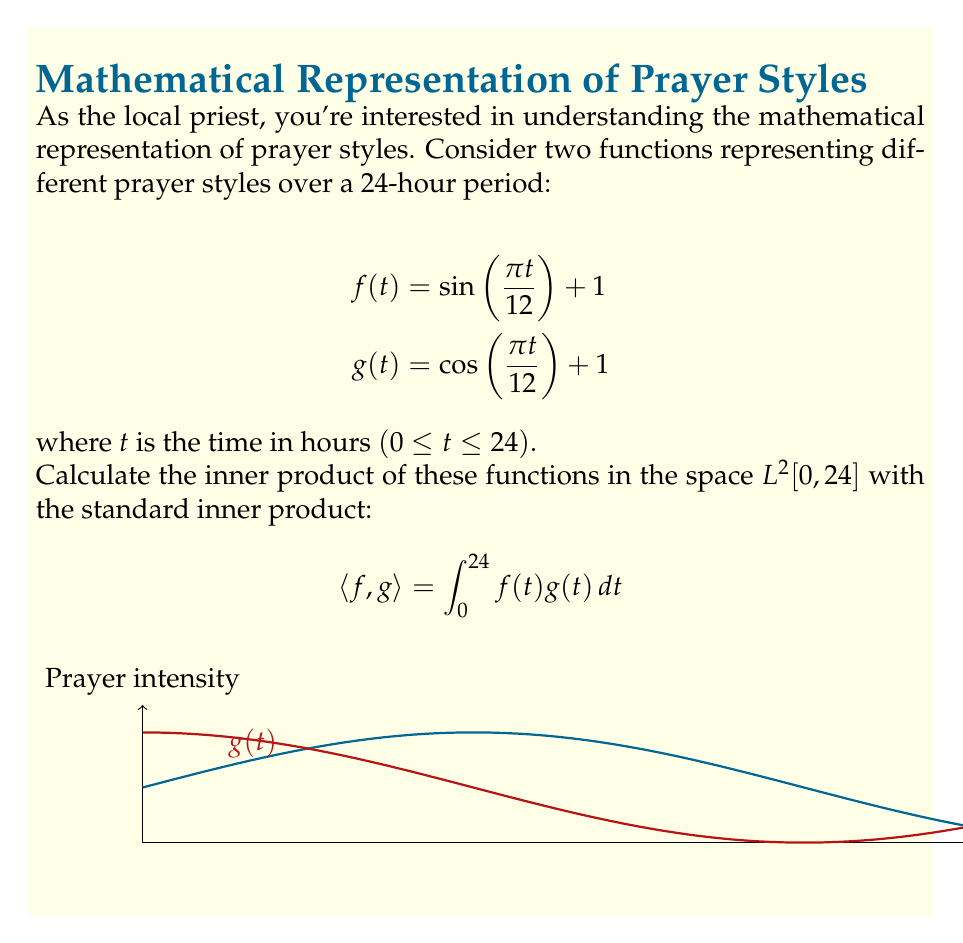Can you solve this math problem? Let's approach this step-by-step:

1) We need to calculate $\int_0^{24} f(t)g(t)dt$

2) Expand the integrand:
   $f(t)g(t) = (\sin(\frac{\pi t}{12}) + 1)(\cos(\frac{\pi t}{12}) + 1)$
              $= \sin(\frac{\pi t}{12})\cos(\frac{\pi t}{12}) + \sin(\frac{\pi t}{12}) + \cos(\frac{\pi t}{12}) + 1$

3) Now we integrate each term:

   a) $\int_0^{24} \sin(\frac{\pi t}{12})\cos(\frac{\pi t}{12})dt$
      Let $u = \frac{\pi t}{12}$, then $du = \frac{\pi}{12}dt$
      $= \frac{12}{\pi} \int_0^{2\pi} \sin u \cos u du = \frac{12}{\pi} [\frac{1}{2}\sin^2 u]_0^{2\pi} = 0$

   b) $\int_0^{24} \sin(\frac{\pi t}{12})dt = -\frac{12}{\pi}[\cos(\frac{\pi t}{12})]_0^{24} = 0$

   c) $\int_0^{24} \cos(\frac{\pi t}{12})dt = \frac{12}{\pi}[\sin(\frac{\pi t}{12})]_0^{24} = 0$

   d) $\int_0^{24} 1 dt = 24$

4) Sum up all the terms: 0 + 0 + 0 + 24 = 24

Therefore, $\langle f,g \rangle = 24$
Answer: $24$ 